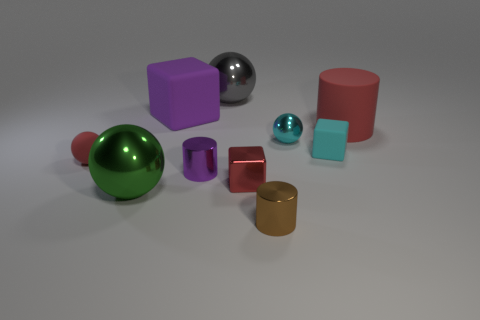Subtract 1 spheres. How many spheres are left? 3 Subtract all balls. How many objects are left? 6 Add 2 large gray metal spheres. How many large gray metal spheres exist? 3 Subtract 0 gray blocks. How many objects are left? 10 Subtract all small brown cylinders. Subtract all cyan rubber cubes. How many objects are left? 8 Add 1 red rubber cylinders. How many red rubber cylinders are left? 2 